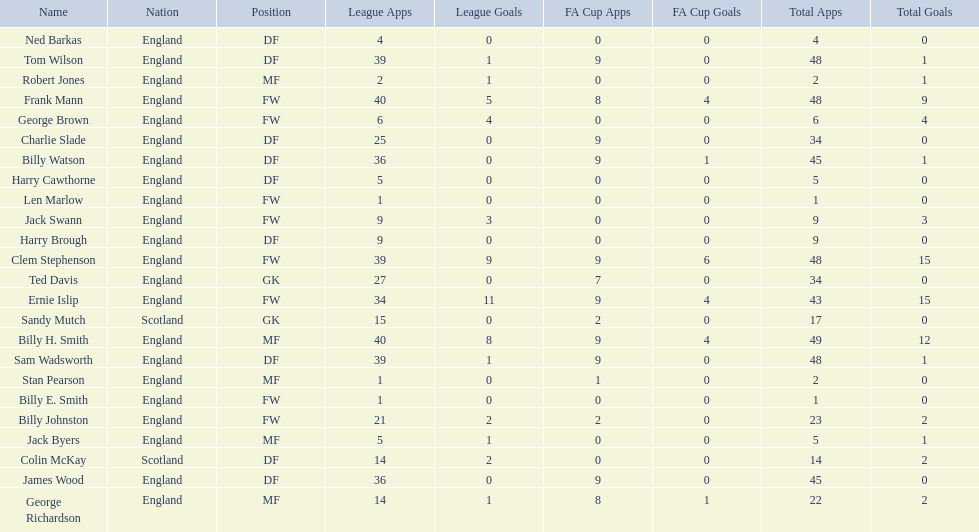What are the number of league apps ted davis has? 27. 